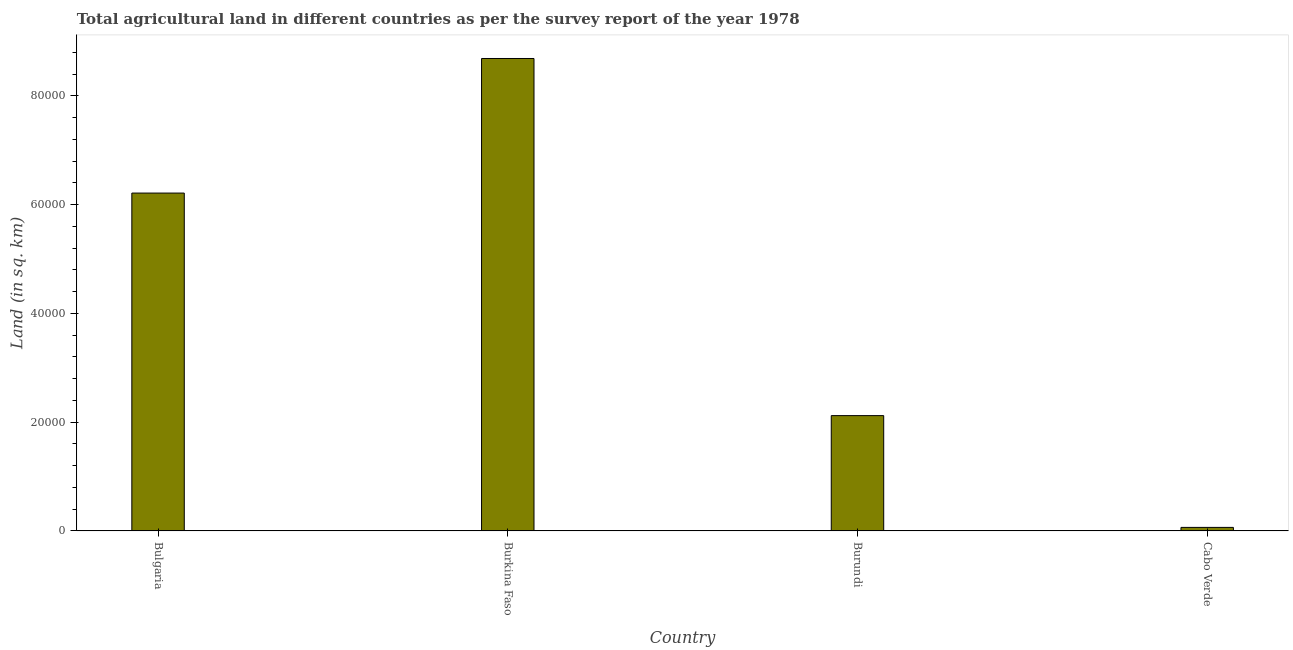Does the graph contain any zero values?
Your answer should be compact. No. What is the title of the graph?
Ensure brevity in your answer.  Total agricultural land in different countries as per the survey report of the year 1978. What is the label or title of the X-axis?
Your answer should be very brief. Country. What is the label or title of the Y-axis?
Your response must be concise. Land (in sq. km). What is the agricultural land in Cabo Verde?
Your answer should be compact. 650. Across all countries, what is the maximum agricultural land?
Your response must be concise. 8.68e+04. Across all countries, what is the minimum agricultural land?
Keep it short and to the point. 650. In which country was the agricultural land maximum?
Your response must be concise. Burkina Faso. In which country was the agricultural land minimum?
Make the answer very short. Cabo Verde. What is the sum of the agricultural land?
Your response must be concise. 1.71e+05. What is the difference between the agricultural land in Burkina Faso and Burundi?
Your answer should be compact. 6.56e+04. What is the average agricultural land per country?
Keep it short and to the point. 4.27e+04. What is the median agricultural land?
Your answer should be very brief. 4.17e+04. In how many countries, is the agricultural land greater than 64000 sq. km?
Provide a succinct answer. 1. What is the ratio of the agricultural land in Burundi to that in Cabo Verde?
Your answer should be very brief. 32.62. Is the agricultural land in Bulgaria less than that in Burundi?
Give a very brief answer. No. What is the difference between the highest and the second highest agricultural land?
Provide a short and direct response. 2.47e+04. What is the difference between the highest and the lowest agricultural land?
Ensure brevity in your answer.  8.62e+04. In how many countries, is the agricultural land greater than the average agricultural land taken over all countries?
Your answer should be very brief. 2. How many bars are there?
Make the answer very short. 4. Are all the bars in the graph horizontal?
Provide a succinct answer. No. Are the values on the major ticks of Y-axis written in scientific E-notation?
Offer a very short reply. No. What is the Land (in sq. km) in Bulgaria?
Your answer should be compact. 6.21e+04. What is the Land (in sq. km) of Burkina Faso?
Your answer should be very brief. 8.68e+04. What is the Land (in sq. km) in Burundi?
Provide a short and direct response. 2.12e+04. What is the Land (in sq. km) of Cabo Verde?
Your response must be concise. 650. What is the difference between the Land (in sq. km) in Bulgaria and Burkina Faso?
Keep it short and to the point. -2.47e+04. What is the difference between the Land (in sq. km) in Bulgaria and Burundi?
Offer a terse response. 4.09e+04. What is the difference between the Land (in sq. km) in Bulgaria and Cabo Verde?
Give a very brief answer. 6.15e+04. What is the difference between the Land (in sq. km) in Burkina Faso and Burundi?
Your answer should be compact. 6.56e+04. What is the difference between the Land (in sq. km) in Burkina Faso and Cabo Verde?
Make the answer very short. 8.62e+04. What is the difference between the Land (in sq. km) in Burundi and Cabo Verde?
Offer a very short reply. 2.06e+04. What is the ratio of the Land (in sq. km) in Bulgaria to that in Burkina Faso?
Your response must be concise. 0.71. What is the ratio of the Land (in sq. km) in Bulgaria to that in Burundi?
Your answer should be very brief. 2.93. What is the ratio of the Land (in sq. km) in Bulgaria to that in Cabo Verde?
Offer a very short reply. 95.55. What is the ratio of the Land (in sq. km) in Burkina Faso to that in Burundi?
Make the answer very short. 4.1. What is the ratio of the Land (in sq. km) in Burkina Faso to that in Cabo Verde?
Your response must be concise. 133.62. What is the ratio of the Land (in sq. km) in Burundi to that in Cabo Verde?
Keep it short and to the point. 32.62. 